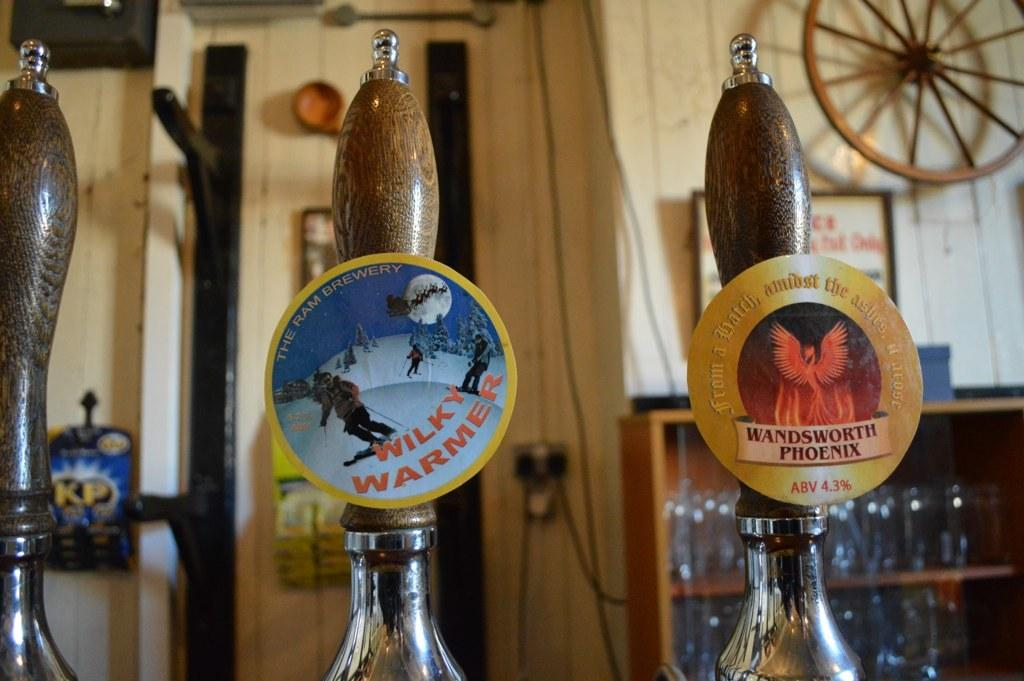<image>
Describe the image concisely. Beer handle for Wilky's Warmer next to Wandsworth Phoenix. 